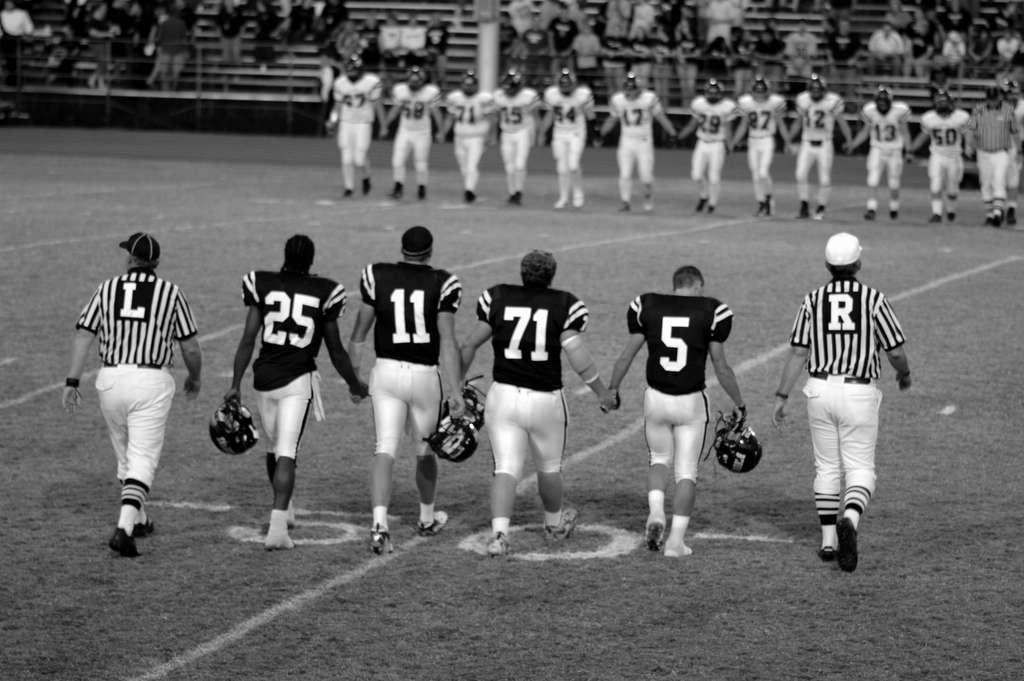What number comes after the player on the far right?
Offer a terse response. 5. What does the right referee's uniform say?
Provide a short and direct response. R. 